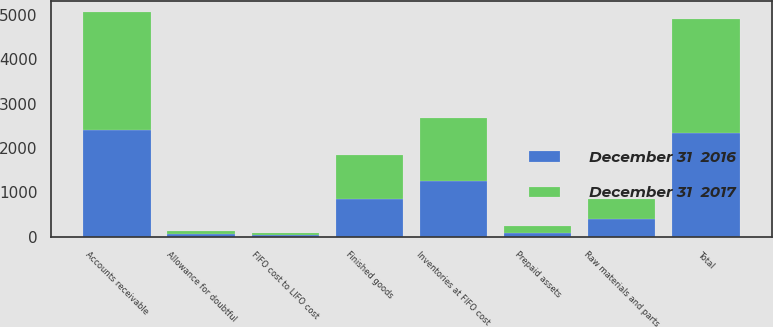<chart> <loc_0><loc_0><loc_500><loc_500><stacked_bar_chart><ecel><fcel>Accounts receivable<fcel>Allowance for doubtful<fcel>Total<fcel>Finished goods<fcel>Raw materials and parts<fcel>Inventories at FIFO cost<fcel>FIFO cost to LIFO cost<fcel>Prepaid assets<nl><fcel>December 31  2017<fcel>2645.6<fcel>71.5<fcel>2574.1<fcel>974.3<fcel>438.7<fcel>1413<fcel>32.9<fcel>153.5<nl><fcel>December 31  2016<fcel>2408.8<fcel>67.6<fcel>2341.2<fcel>860<fcel>408.4<fcel>1268.4<fcel>51<fcel>98.3<nl></chart> 